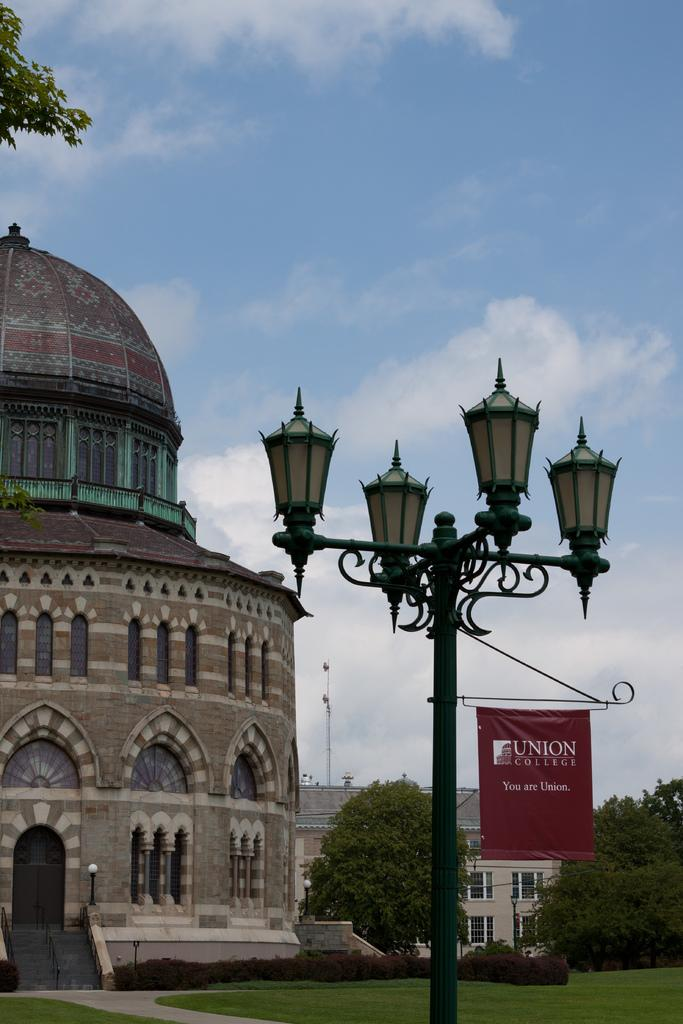What is located in the foreground of the image? There is a pole in the foreground of the image. What is attached to the pole? There is a banner on the pole. What can be seen in the background of the image? There is a building, plants, grass, and trees in the background of the image. What is visible at the top of the image? The sky is visible at the top of the image, and there is a cloud in the sky. What year is depicted in the image? There is no indication of a specific year in the image. How does the pail help in the image? There is no pail present in the image, so it cannot help in any way. 